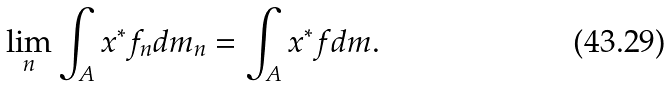Convert formula to latex. <formula><loc_0><loc_0><loc_500><loc_500>\lim _ { n } \int _ { A } x ^ { * } f _ { n } d m _ { n } = \int _ { A } x ^ { * } f d m .</formula> 